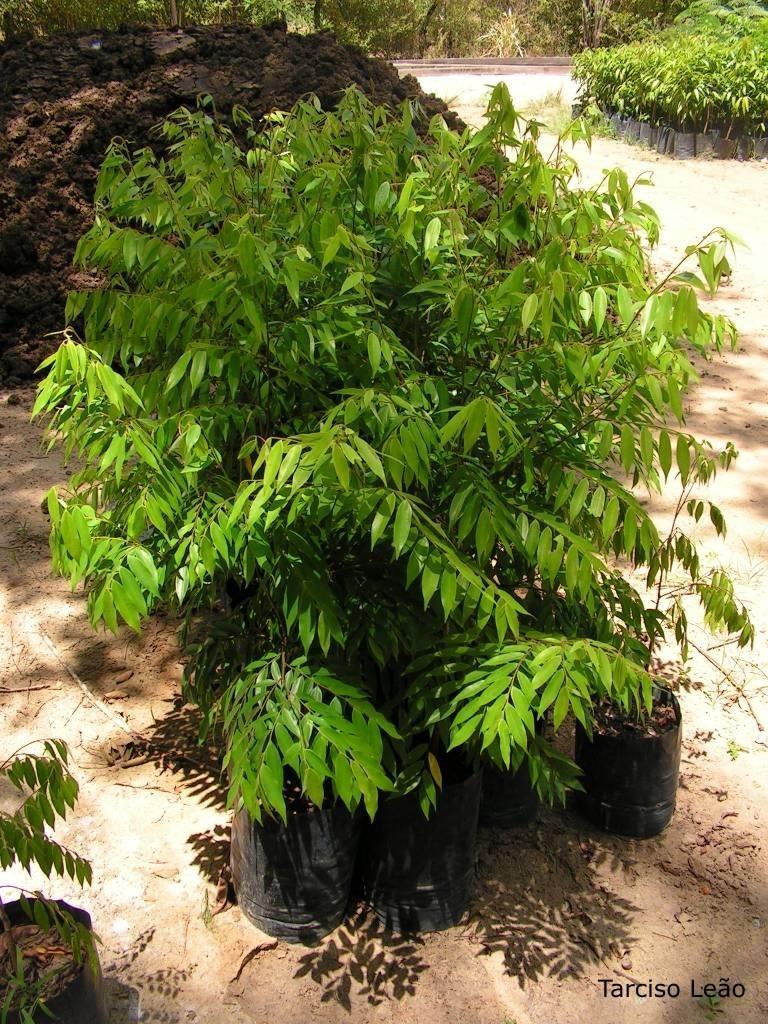Describe this image in one or two sentences. In this picture I can see there are few plants and there is black soil in the backdrop and there are few more plants on to right side and there are trees in the backdrop. 